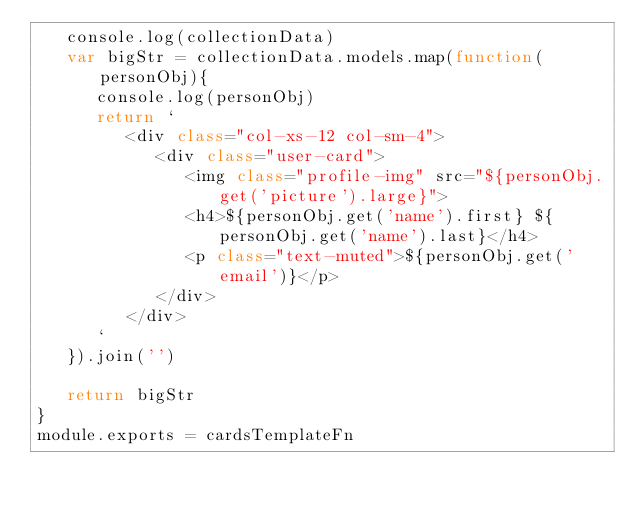<code> <loc_0><loc_0><loc_500><loc_500><_JavaScript_>   console.log(collectionData)
   var bigStr = collectionData.models.map(function(personObj){
      console.log(personObj)
      return `
         <div class="col-xs-12 col-sm-4">
            <div class="user-card">
               <img class="profile-img" src="${personObj.get('picture').large}">
               <h4>${personObj.get('name').first} ${personObj.get('name').last}</h4>
               <p class="text-muted">${personObj.get('email')}</p>
            </div>
         </div>
      `
   }).join('')

   return bigStr
}
module.exports = cardsTemplateFn
</code> 